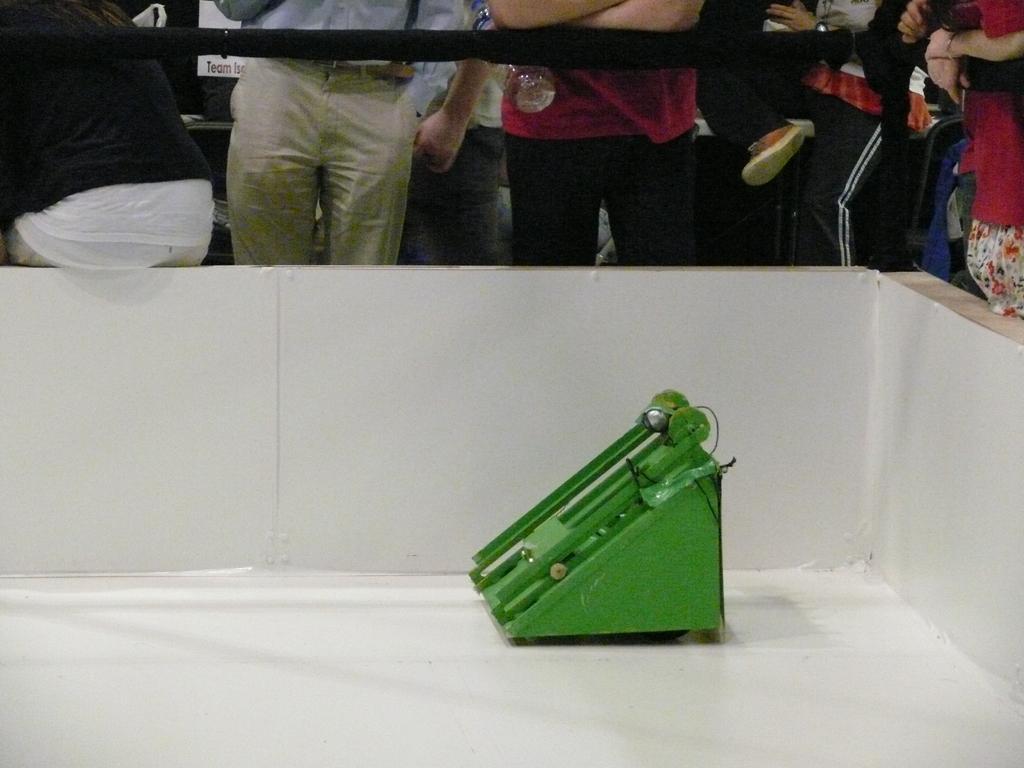Could you give a brief overview of what you see in this image? In this picture I can observe a green color device placed on the floor. I can observe white color wall and black color railing. Behind the railing there are some people standing. 